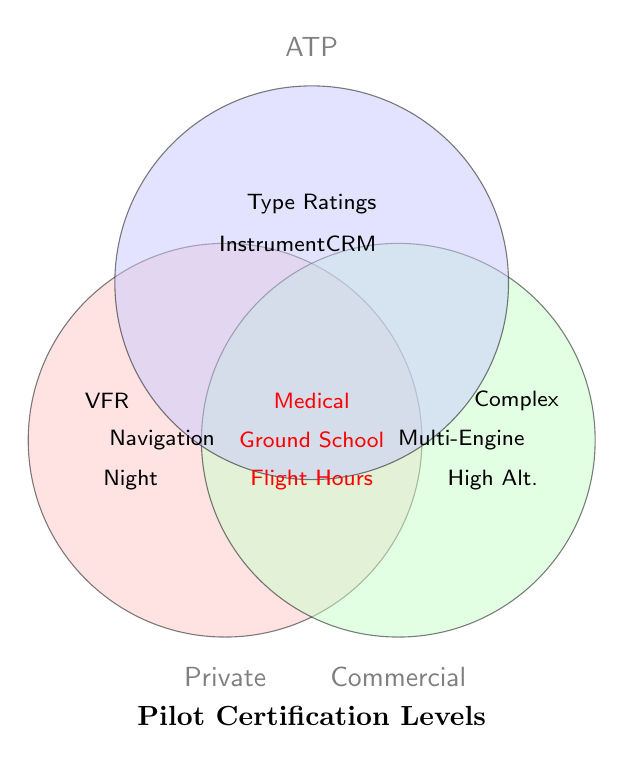How many pilot certification levels are shown in the diagram? The Venn diagram shows three main circles, each labeled with a different certification level. These are "Private," "Commercial," and "ATP"
Answer: Three Which certifications are common to all pilot levels? The certifications that are common to all levels are in the overlapping area shared by all three circles. These are labeled as "Medical Certificate," "Ground School," and "Flight Hours"
Answer: Medical Certificate, Ground School, Flight Hours What certifications are specific only to Commercial pilots? The certifications specific to Commercial pilots are outside the intersection with the other circles but inside the circle labeled "Commercial." These include "Complex Aircraft," "High Altitude," and "Multi-Engine"
Answer: Complex Aircraft, High Altitude, Multi-Engine Which pilot level requires "Night Flying" certification? The "Night Flying" certification is within the "Private" circle and not overlapping with any other circles, so it is specific to Private pilots
Answer: Private Are there any certifications that overlap only between Private and Commercial, excluding ATP? The areas that overlap only between Private and Commercial, excluding the ATP circle, do not contain any specific certifications
Answer: No Which certifications are required only for ATP pilots and not shared with any other levels? The certifications for ATP pilots that do not overlap with any other circles are "Type Ratings," "Instrument Rating," and "Crew Resource Management"
Answer: Type Ratings, Instrument Rating, Crew Resource Management How many certifications are shared between all three certification levels? The certifications in the area where all three circles overlap are shared among all levels. Counting these gives three certifications
Answer: Three Is "Basic Navigation" required for Commercial pilots? The "Basic Navigation" certification is listed within the "Private" circle but does not intersect with "Commercial," so it is not required for Commercial pilots
Answer: No 